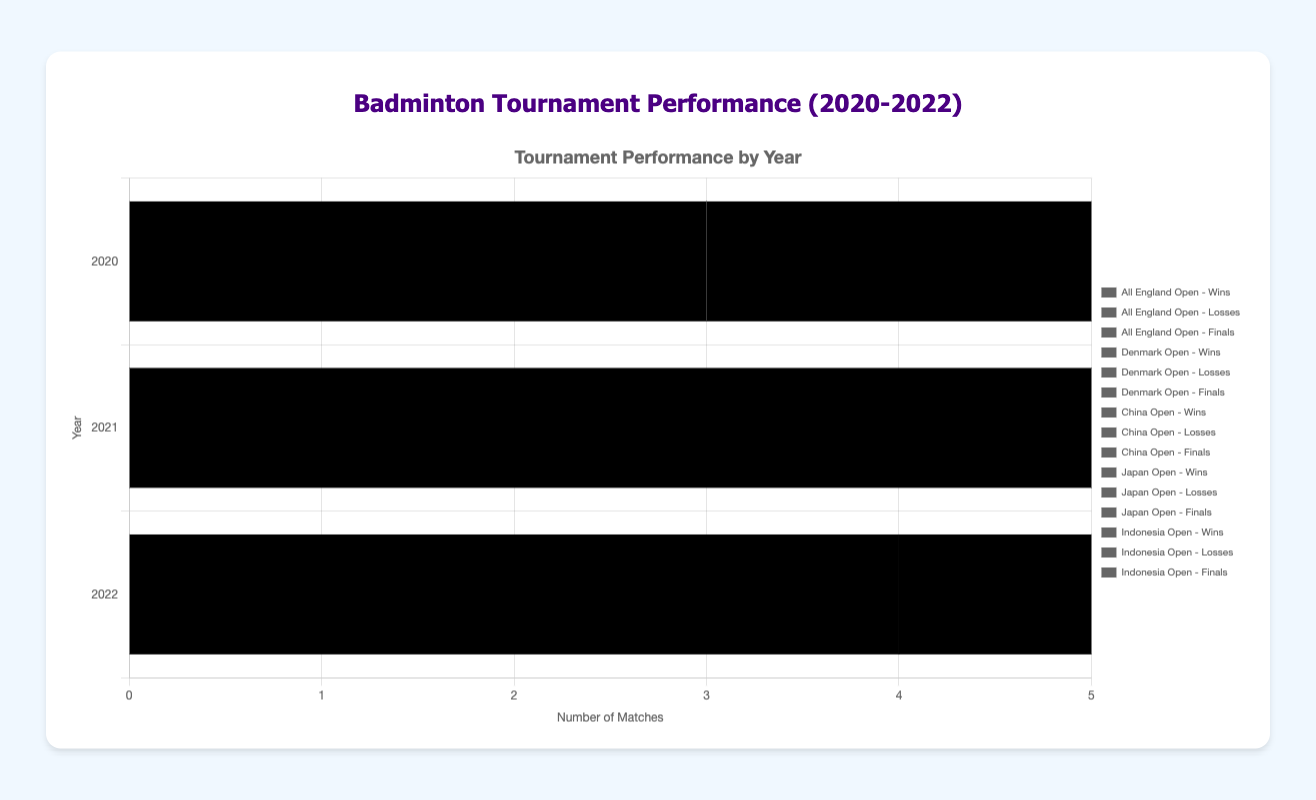Which tournament had the most wins in 2020? By looking at the bars labeled for 2020, we can see that the Indonesia Open has the tallest bar in the Wins category with 5 wins.
Answer: Indonesia Open How many total finals did I reach across all tournaments in 2021? Sum the number of finals for each tournament in 2021: All England Open (2) + Denmark Open (0) + China Open (1) + Japan Open (0) + Indonesia Open (1). This gives us 2 + 0 + 1 + 0 + 1 = 4.
Answer: 4 Which tournament had the least losses in 2022? By looking at the bars marked for 2022, we see that the Denmark Open has the shortest bar for losses with 0 losses.
Answer: Denmark Open Did I perform better in terms of wins at the China Open or Japan Open in 2021? Compare the heights of the bars for wins in both tournaments for the year 2021. China Open has 4 wins, while Japan Open has 2 wins.
Answer: China Open What is the total number of wins across the All England Open tournaments from 2020 to 2022? Add up the wins for All England Open across all three years: 3 (2020) + 5 (2021) + 4 (2022). This equals 3 + 5 + 4 = 12.
Answer: 12 Which tournament had the highest number of wins in 2021? By looking at the bars for wins in 2021, the All England Open has the longest bar with 5 wins.
Answer: All England Open Between which two years did the Denmark Open show the greatest improvement in wins? Compare the wins across the years for Denmark Open. From 2020 to 2021, there was a decrease (4 to 3), but from 2021 to 2022, there was an increase (3 to 5). The greatest improvement is from 2021 to 2022.
Answer: 2021 to 2022 How many more wins did I have in the Indonesia Open in 2020 compared to 2021? Subtract the wins in 2021 from the wins in 2020 for the Indonesia Open. This is 5 (2020) - 3 (2021) = 2.
Answer: 2 In which year did I reach the highest number of finals at the Japan Open? By comparing the heights of the bars for finals in each year for the Japan Open, the highest is in 2022 with 1 final.
Answer: 2022 